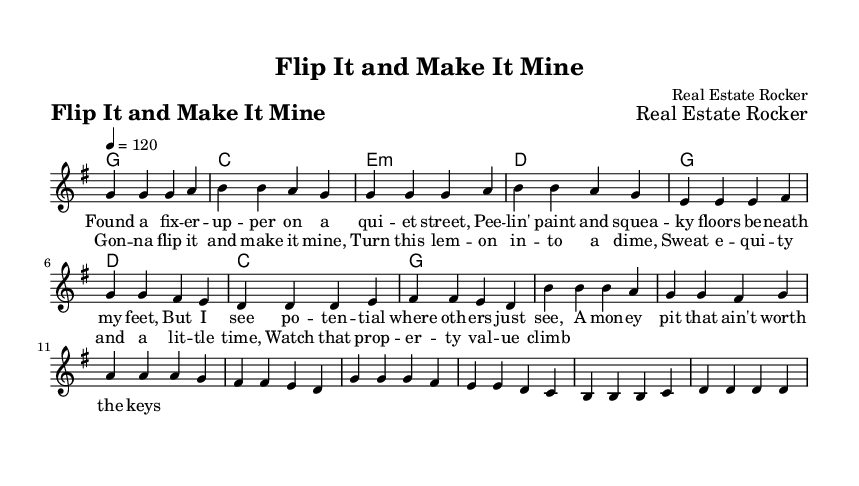What is the key signature of this music? The key signature is G major, which has one sharp (F#). This can be identified in the global variables section of the code where it states "\key g \major".
Answer: G major What is the time signature of the piece? The time signature is 4/4, which is indicated in the global section with "\time 4/4". This means there are four beats in each measure and the quarter note gets one beat.
Answer: 4/4 What is the tempo marking for the composition? The tempo marking is 120 beats per minute, clearly stated in the global section with "\tempo 4 = 120". This indicates the speed of the piece.
Answer: 120 How many measures are in the chorus? The chorus consists of 8 measures, which can be counted directly from the melody and harmonies sections under the chorus part, where there are 8 groups of notes and chords.
Answer: 8 What is the first lyric line of the verse? The first lyric line of the verse is "Found a fix -- er -- up -- per on a qui -- et street," which is shown in the verse lyrics section that outlines the words corresponding to the melody.
Answer: Found a fix -- er -- up -- per on a qui -- et street How many chords are used in the verse section? There are 4 unique chords in the verse section: G, C, E minor, and D. These chords can be identified by looking at the harmonies section of the code where the chords for the verse are listed.
Answer: 4 What is the main theme of the lyrics? The main theme of the lyrics revolves around property investment and flipping houses, highlighted through phrases about potential and value in the lyrics for both verse and chorus. This theme is derived from the content of the verse and chorus lyrics.
Answer: Property investment 